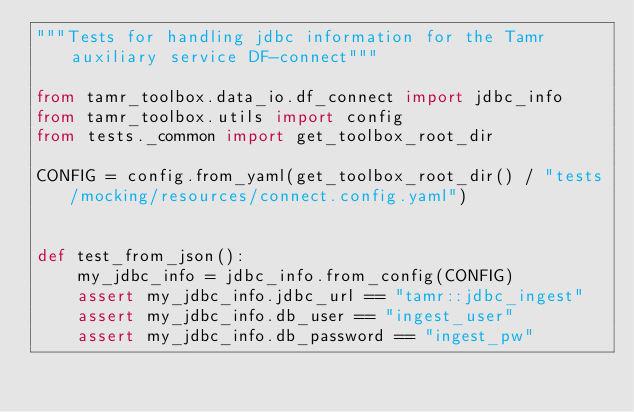<code> <loc_0><loc_0><loc_500><loc_500><_Python_>"""Tests for handling jdbc information for the Tamr auxiliary service DF-connect"""

from tamr_toolbox.data_io.df_connect import jdbc_info
from tamr_toolbox.utils import config
from tests._common import get_toolbox_root_dir

CONFIG = config.from_yaml(get_toolbox_root_dir() / "tests/mocking/resources/connect.config.yaml")


def test_from_json():
    my_jdbc_info = jdbc_info.from_config(CONFIG)
    assert my_jdbc_info.jdbc_url == "tamr::jdbc_ingest"
    assert my_jdbc_info.db_user == "ingest_user"
    assert my_jdbc_info.db_password == "ingest_pw"
</code> 